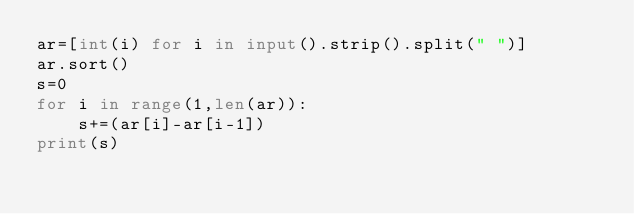Convert code to text. <code><loc_0><loc_0><loc_500><loc_500><_Python_>ar=[int(i) for i in input().strip().split(" ")]
ar.sort()
s=0
for i in range(1,len(ar)):
    s+=(ar[i]-ar[i-1])
print(s)</code> 